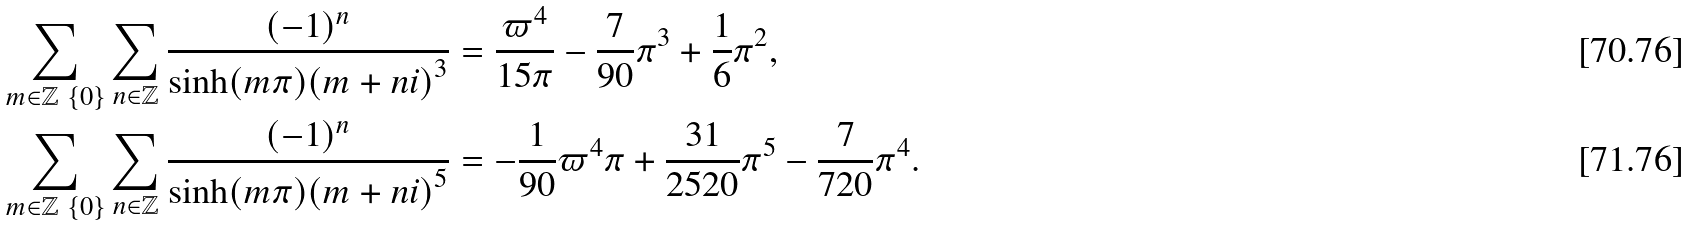<formula> <loc_0><loc_0><loc_500><loc_500>& \sum _ { m \in \mathbb { Z } \ \{ 0 \} } \sum _ { n \in \mathbb { Z } } \frac { ( - 1 ) ^ { n } } { \sinh ( m \pi ) { ( m + n i ) } ^ { 3 } } = \frac { \varpi ^ { 4 } } { 1 5 \pi } - \frac { 7 } { 9 0 } \pi ^ { 3 } + \frac { 1 } { 6 } \pi ^ { 2 } , \\ & \sum _ { m \in \mathbb { Z } \ \{ 0 \} } \sum _ { n \in \mathbb { Z } } \frac { ( - 1 ) ^ { n } } { \sinh ( m \pi ) { ( m + n i ) } ^ { 5 } } = - \frac { 1 } { 9 0 } \varpi ^ { 4 } \pi + \frac { 3 1 } { 2 5 2 0 } \pi ^ { 5 } - \frac { 7 } { 7 2 0 } \pi ^ { 4 } .</formula> 